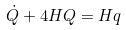<formula> <loc_0><loc_0><loc_500><loc_500>\dot { Q } + 4 H Q = H q</formula> 